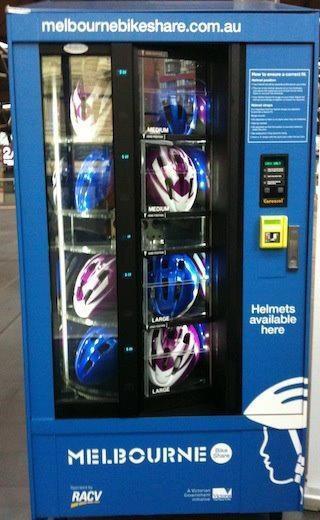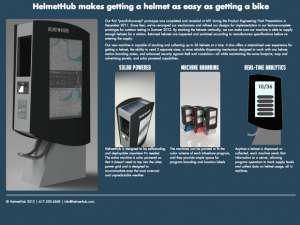The first image is the image on the left, the second image is the image on the right. Considering the images on both sides, is "There is a at least one person in the image on the left." valid? Answer yes or no. No. 